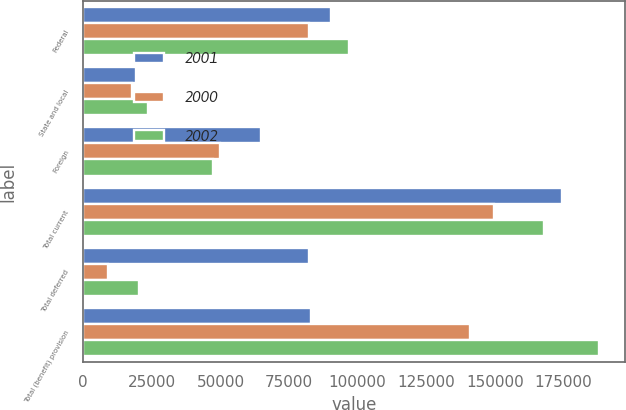Convert chart to OTSL. <chart><loc_0><loc_0><loc_500><loc_500><stacked_bar_chart><ecel><fcel>Federal<fcel>State and local<fcel>Foreign<fcel>Total current<fcel>Total deferred<fcel>Total (benefit) provision<nl><fcel>2001<fcel>90312<fcel>19110<fcel>64922<fcel>174344<fcel>82124<fcel>82864<nl><fcel>2000<fcel>82124<fcel>17828<fcel>49886<fcel>149838<fcel>9083<fcel>140755<nl><fcel>2002<fcel>96864<fcel>23498<fcel>47387<fcel>167749<fcel>20361<fcel>188110<nl></chart> 